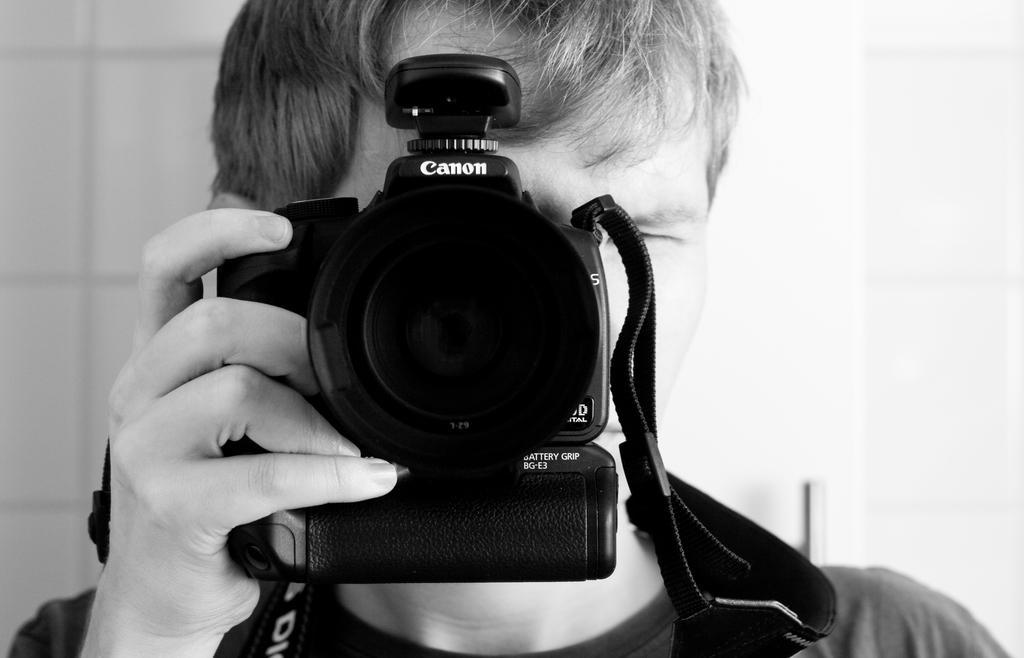What is the main subject of the image? There is a person in the image. What is the person holding in the image? The person is holding a camera. What color is the silver finger in the image? There is no silver finger present in the image. 